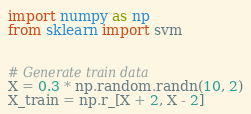Convert code to text. <code><loc_0><loc_0><loc_500><loc_500><_Python_>import numpy as np
from sklearn import svm


# Generate train data
X = 0.3 * np.random.randn(10, 2)
X_train = np.r_[X + 2, X - 2]</code> 